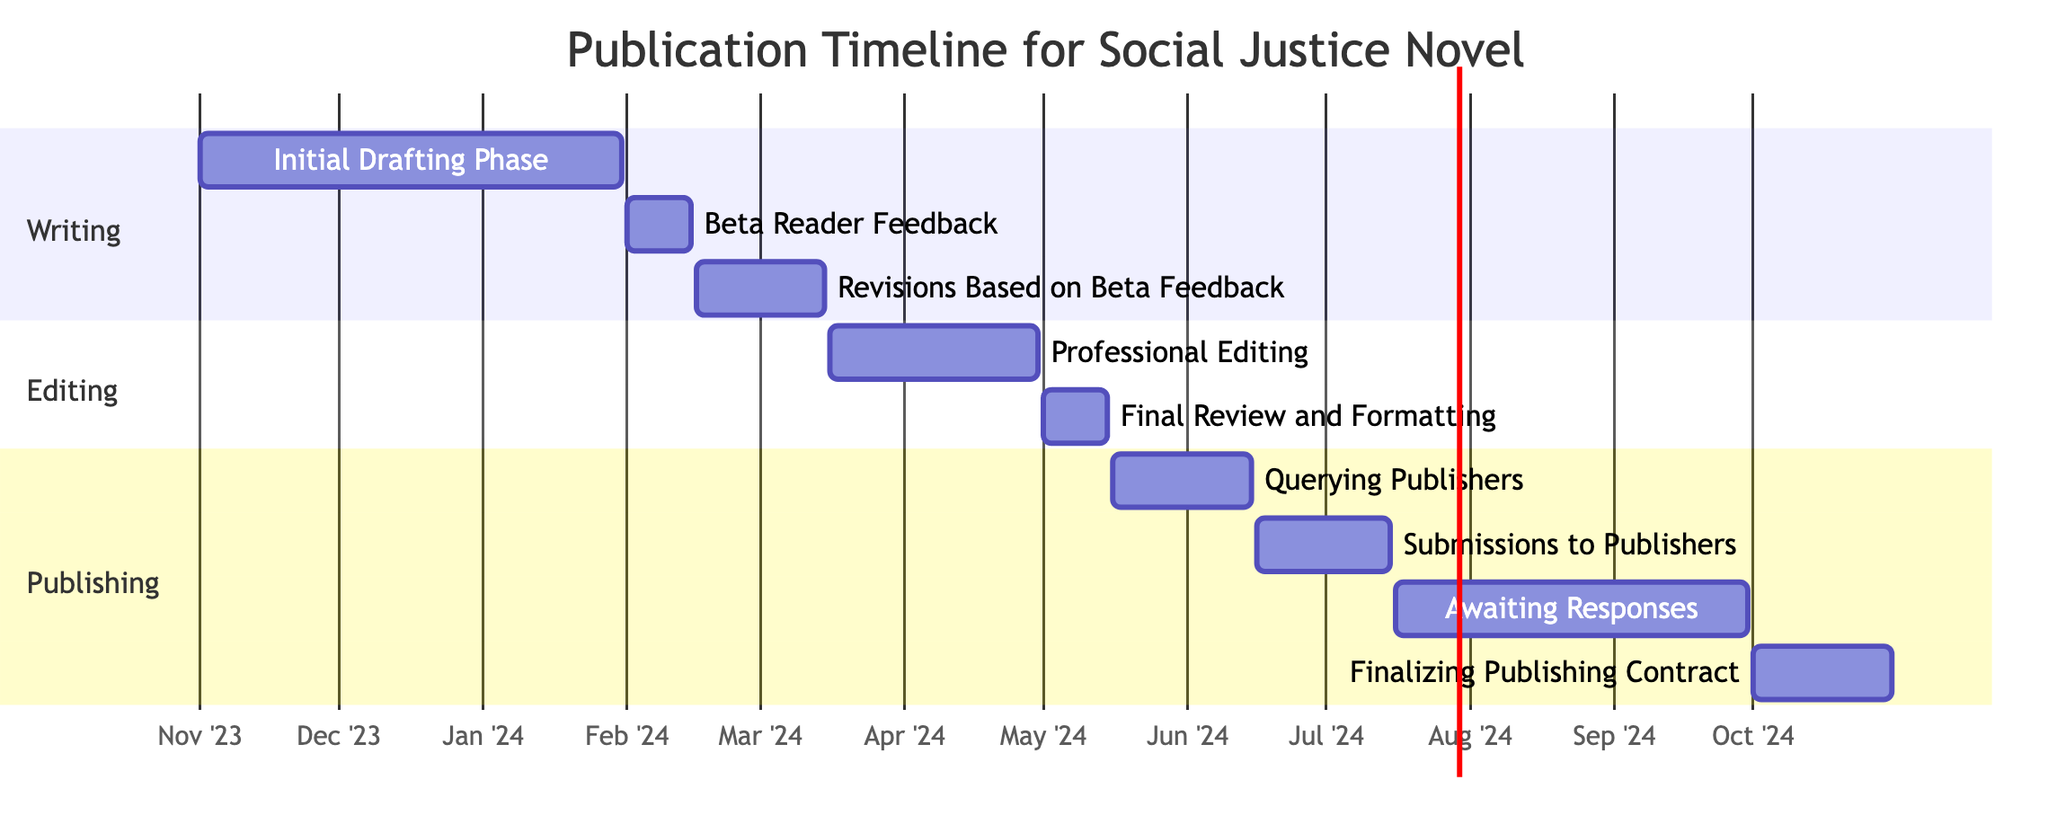What is the duration of the Professional Editing phase? The Professional Editing phase starts on March 16, 2024, and ends on April 30, 2024. The duration can be calculated by counting the days from the start date to the end date, which is 45 days.
Answer: 45 days When does the Awaiting Responses phase start? The Awaiting Responses phase begins on July 16, 2024, as indicated in the timeline. There's a clear start date provided in the diagram.
Answer: July 16, 2024 How many total tasks are outlined in the Gantt chart? There are a total of 9 tasks depicted in the Gantt chart, including all phases: Initial Drafting, Beta Reader Feedback, Revisions, etc. Each task is a distinct entry in the diagram.
Answer: 9 Which task immediately follows Final Review and Formatting? The task that follows Final Review and Formatting is Querying Publishers, beginning on May 16, 2024. This can be determined by looking directly after the Final Review task in the sequencing.
Answer: Querying Publishers What is the end date for Submissions to Publishers? Submissions to Publishers ends on July 15, 2024. This can be found directly in the diagram at the end of the specified task.
Answer: July 15, 2024 How long is the Beta Reader Feedback phase? The Beta Reader Feedback phase lasts from February 1, 2024, to February 15, 2024, which amounts to 14 days in total. This duration can be calculated from its start and end dates.
Answer: 14 days Which task has the longest duration? The task with the longest duration is the Initial Drafting Phase, which spans from November 1, 2023, to January 31, 2024, totaling 91 days. This was determined by calculating durations of all tasks and comparing them.
Answer: Initial Drafting Phase When is the Finalizing Publishing Contract phase? The Finalizing Publishing Contract phase occurs from October 1, 2024, to October 31, 2024. This information can be directly read from the diagram.
Answer: October 1, 2024 What is the relationship between the Revisions Based on Beta Feedback and Beta Reader Feedback? Revisions Based on Beta Feedback immediately follows the Beta Reader Feedback task, starting on February 16, 2024. The Gantt chart shows a sequential relationship where the latter is dependent on the former’s completion.
Answer: Sequential relationship 